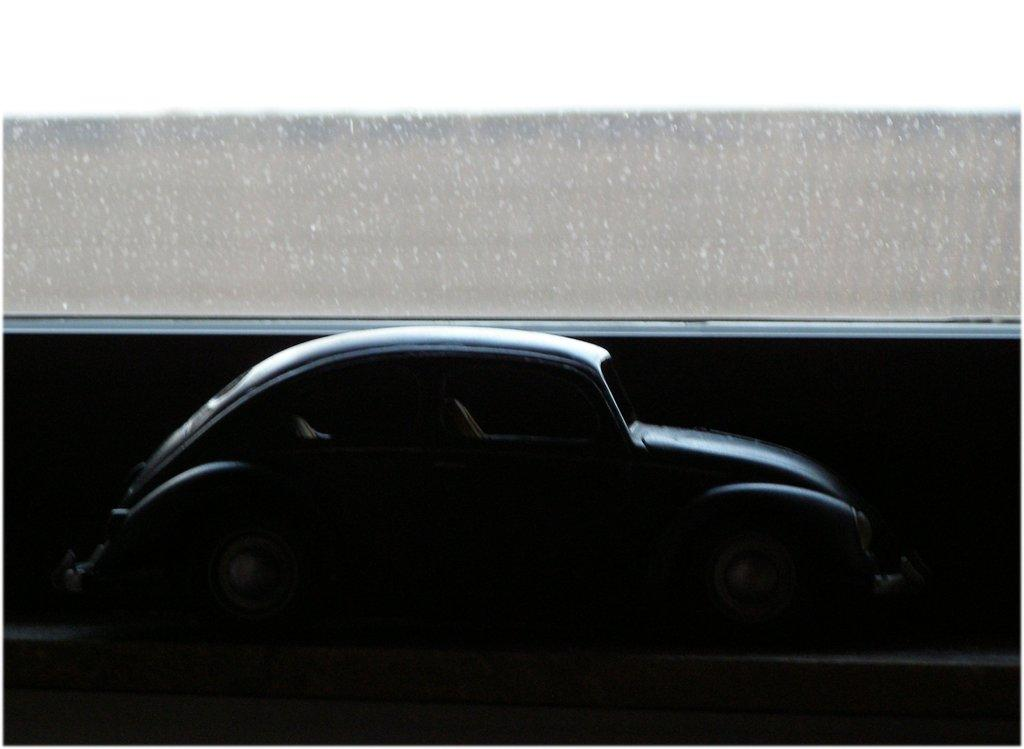What is the main subject of the image? The main subject of the image is a toy car. What is the color of the surface the toy car is on? The toy car is on a black surface. What other object can be seen in the image besides the toy car? There is an object that looks like a glass in the image. What language is the toy car speaking in the image? Toys do not speak, so there is no language present in the image. What angle is the toy car positioned at in the image? The angle at which the toy car is positioned cannot be determined from the image alone, as it only shows a top-down view. 